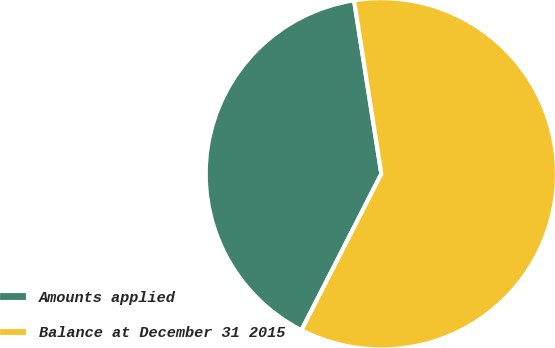<chart> <loc_0><loc_0><loc_500><loc_500><pie_chart><fcel>Amounts applied<fcel>Balance at December 31 2015<nl><fcel>40.0%<fcel>60.0%<nl></chart> 